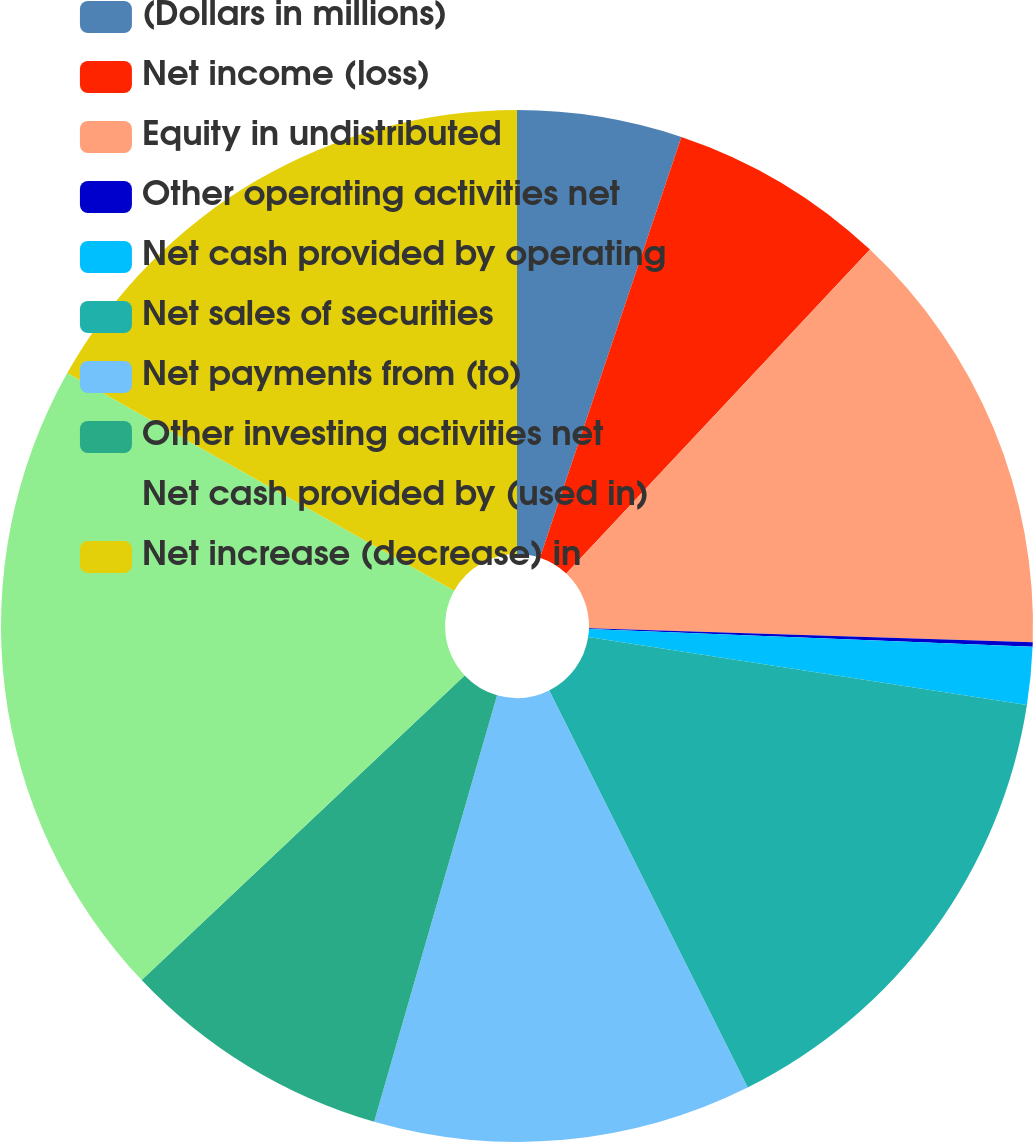Convert chart. <chart><loc_0><loc_0><loc_500><loc_500><pie_chart><fcel>(Dollars in millions)<fcel>Net income (loss)<fcel>Equity in undistributed<fcel>Other operating activities net<fcel>Net cash provided by operating<fcel>Net sales of securities<fcel>Net payments from (to)<fcel>Other investing activities net<fcel>Net cash provided by (used in)<fcel>Net increase (decrease) in<nl><fcel>5.16%<fcel>6.83%<fcel>13.51%<fcel>0.14%<fcel>1.81%<fcel>15.18%<fcel>11.84%<fcel>8.5%<fcel>20.19%<fcel>16.85%<nl></chart> 